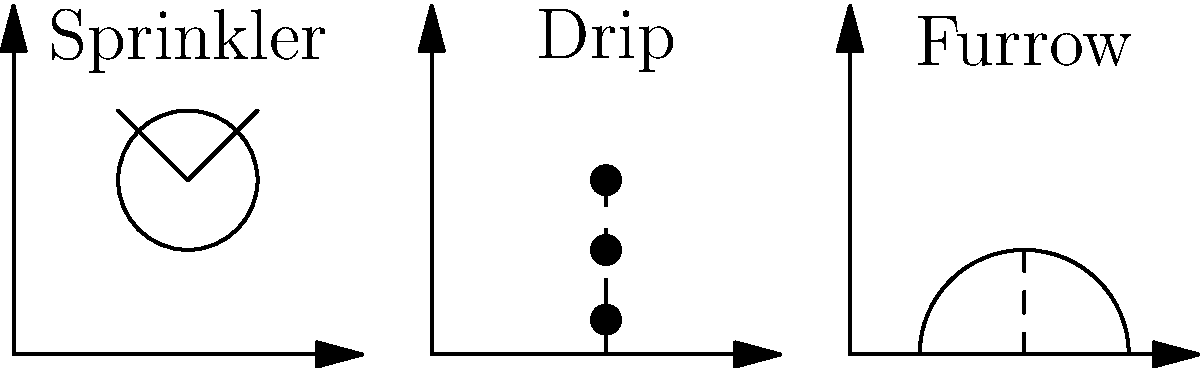Analyze the three irrigation methods shown in the diagram (sprinkler, drip, and furrow) for potato fields. Which method is likely to be the most water-efficient while still providing adequate irrigation for potato crops? Explain your reasoning based on the characteristics of each system and the specific needs of potato plants. To determine the most water-efficient irrigation method for potato fields, we need to consider the characteristics of each system and the needs of potato plants:

1. Sprinkler system:
   - Provides overhead irrigation, simulating rainfall
   - Can cover large areas quickly
   - Prone to water loss through evaporation and wind drift
   - May lead to uneven water distribution

2. Drip system:
   - Delivers water directly to the root zone
   - Minimizes water loss through evaporation
   - Allows for precise control of water application
   - Can be used with mulch to further reduce evaporation

3. Furrow system:
   - Water flows through trenches between crop rows
   - Can be efficient if properly managed
   - May lead to water loss through deep percolation
   - Requires careful land grading to ensure even distribution

Potato plants:
   - Have a relatively shallow root system (typically 12-18 inches deep)
   - Require consistent moisture throughout the growing season
   - Are sensitive to water stress, which can affect tuber quality and yield

Considering these factors:
1. The drip system is likely to be the most water-efficient because:
   - It delivers water directly to the root zone, matching the shallow root system of potatoes
   - It minimizes water loss through evaporation and wind drift
   - It allows for precise control of water application, ensuring consistent moisture

2. The sprinkler system, while effective, may lose more water to evaporation and wind drift

3. The furrow system can be efficient but may lead to water loss through deep percolation beyond the potato's root zone

Therefore, the drip irrigation system is likely to be the most water-efficient while still providing adequate irrigation for potato crops.
Answer: Drip irrigation 